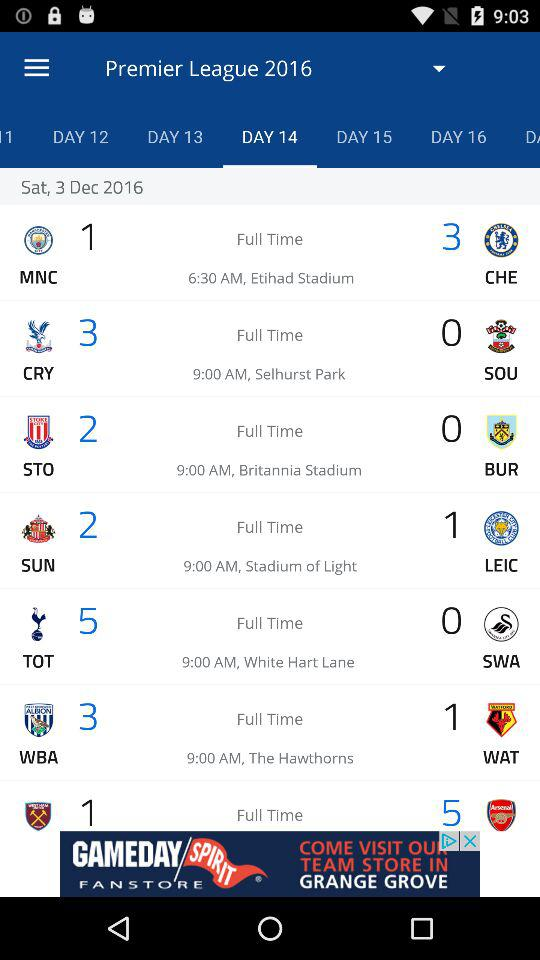Which day is December 3, 2016? The day is Saturday. 